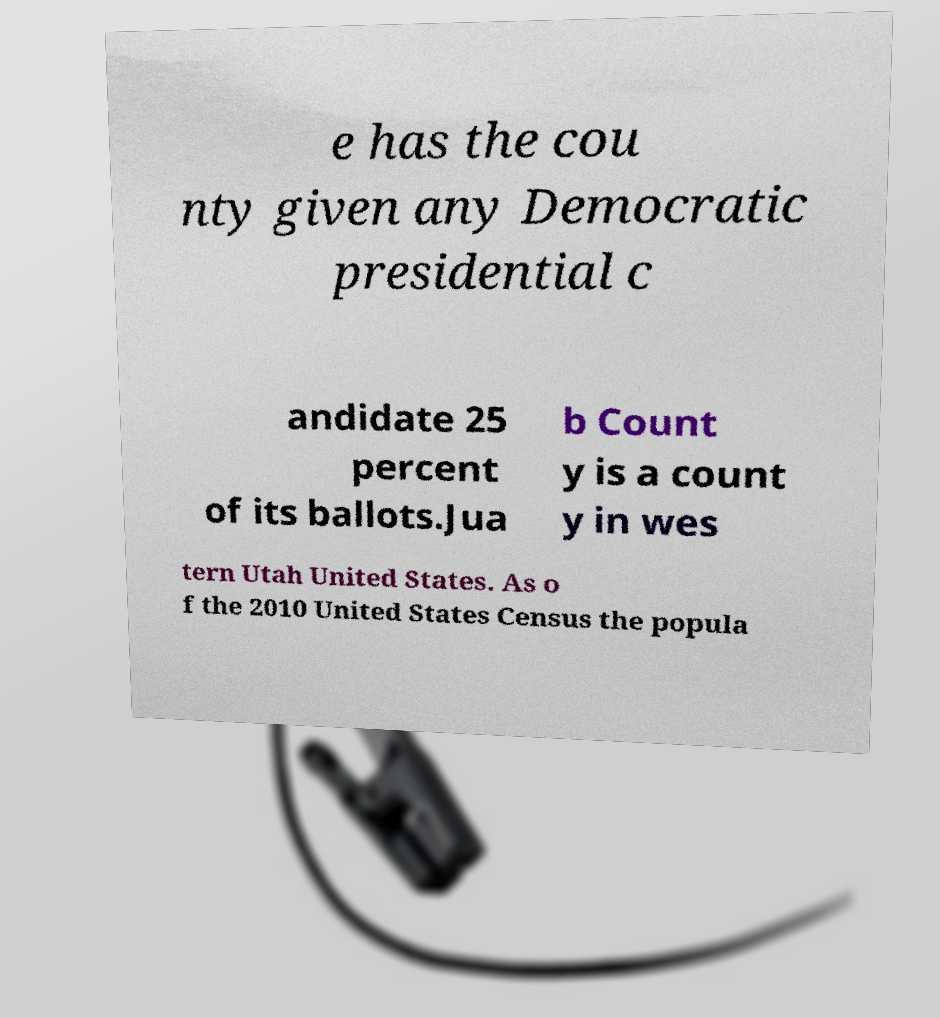Could you assist in decoding the text presented in this image and type it out clearly? e has the cou nty given any Democratic presidential c andidate 25 percent of its ballots.Jua b Count y is a count y in wes tern Utah United States. As o f the 2010 United States Census the popula 